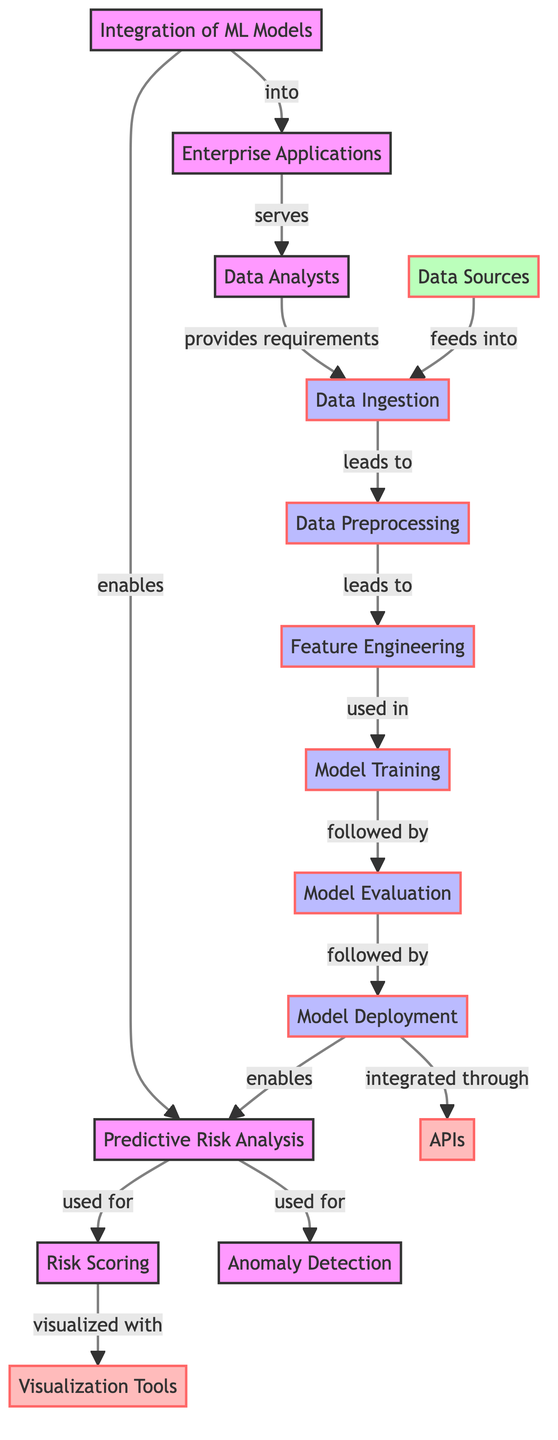What is the total number of nodes in the diagram? The diagram lists a total of 15 distinct nodes, which represent key concepts in the integration of machine learning models for predictive risk analysis.
Answer: 15 What is the relationship between "Integration of ML Models" and "Predictive Risk Analysis"? The diagram shows a directed edge from "Integration of ML Models" to "Predictive Risk Analysis" labeled "enables," indicating that the integration of ML models facilitates predictive risk analysis.
Answer: enables Which node feeds into "Data Ingestion"? The diagram indicates that "Data Sources" has a directed edge feeding into "Data Ingestion," meaning that data sources are the input or origin of data that gets ingested for further processing.
Answer: Data Sources How many relationships are there from "Model Deployment"? The diagram shows two directed edges emerging from "Model Deployment": one that leads to "Predictive Risk Analysis" labeled "enables" and another to "APIs" labeled "integrated through." Therefore, there are a total of 2 relationships.
Answer: 2 What is the final step that follows "Model Evaluation"? According to the diagram, the step that follows "Model Evaluation" is "Model Deployment," signifying that after the evaluation of the model is complete, the next action is its deployment.
Answer: Model Deployment Which tools are used for visualization according to the diagram? The diagram indicates that "Visualization Tools" is the node that visualizes the output related to "Risk Scoring," highlighting the importance of visualization in understanding the risk analysis results.
Answer: Visualization Tools What does "Predictive Risk Analysis" utilize "Risk Scoring" for? The relationship between "Predictive Risk Analysis" and "Risk Scoring" is denoted by the edge labeled "used for," which means that risk scoring is a component or method utilized within predictive risk analysis to evaluate risk levels.
Answer: used for What leads to "Feature Engineering"? The flow in the diagram shows that "Data Preprocessing" leads to "Feature Engineering," meaning that preprocessing the data is a necessary step before the feature engineering process can occur.
Answer: Data Preprocessing What role do "Data Analysts" play according to the diagram? "Data Analysts" serve the role of providing requirements to "Data Ingestion," indicating their involvement in defining what data needs to be ingested for analysis.
Answer: serves 